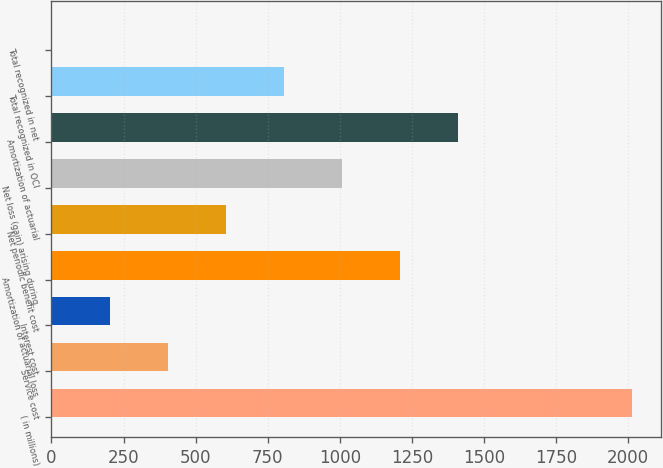Convert chart. <chart><loc_0><loc_0><loc_500><loc_500><bar_chart><fcel>( in millions)<fcel>Service cost<fcel>Interest cost<fcel>Amortization of actuarial loss<fcel>Net periodic benefit cost<fcel>Net loss (gain) arising during<fcel>Amortization of actuarial<fcel>Total recognized in OCI<fcel>Total recognized in net<nl><fcel>2015<fcel>403.08<fcel>201.59<fcel>1209.04<fcel>604.57<fcel>1007.55<fcel>1410.53<fcel>806.06<fcel>0.1<nl></chart> 